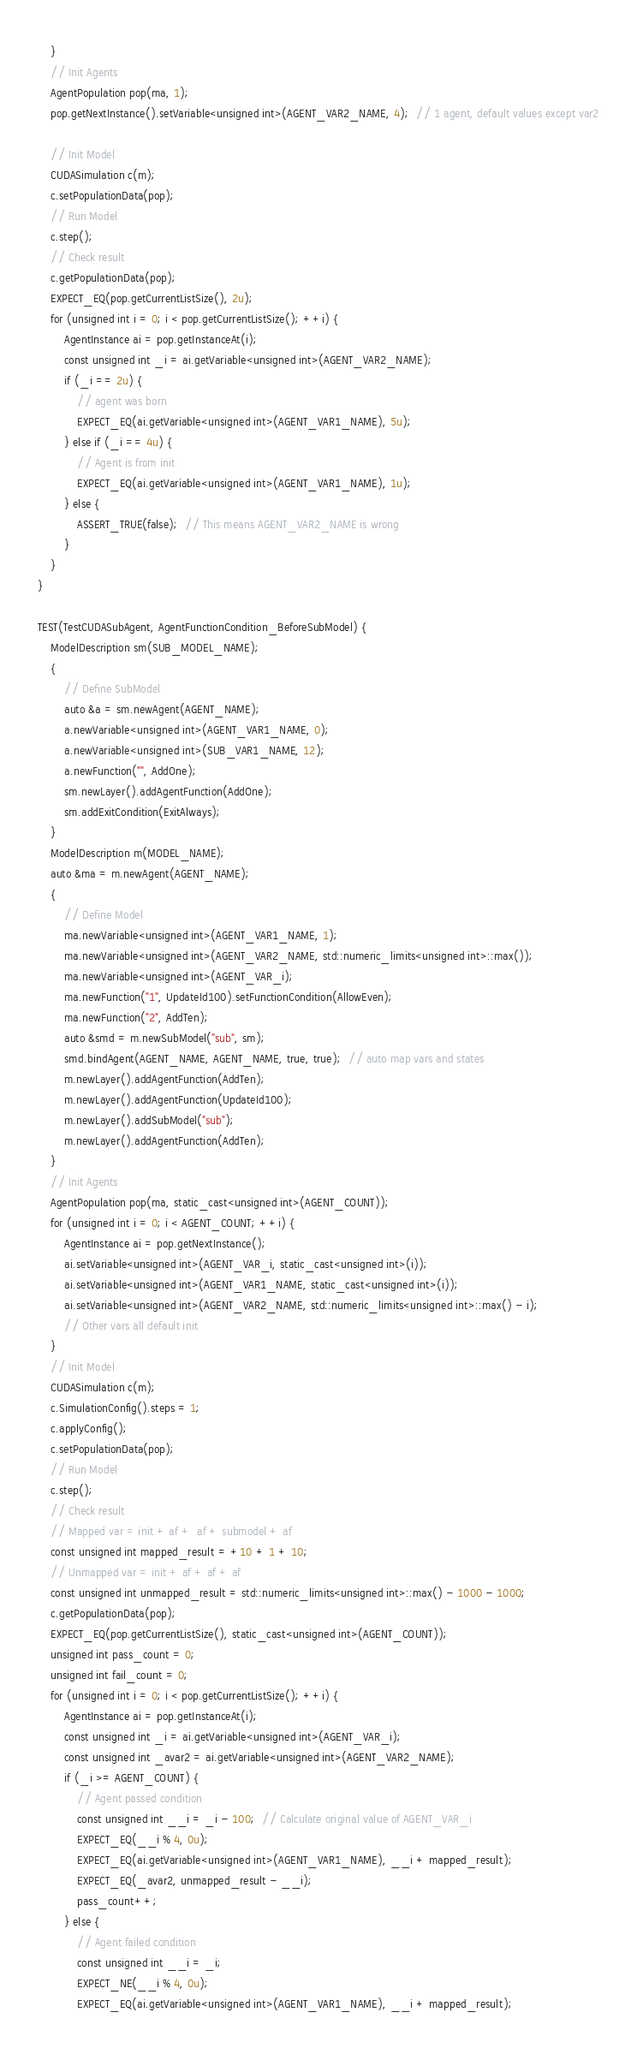Convert code to text. <code><loc_0><loc_0><loc_500><loc_500><_Cuda_>    }
    // Init Agents
    AgentPopulation pop(ma, 1);
    pop.getNextInstance().setVariable<unsigned int>(AGENT_VAR2_NAME, 4);  // 1 agent, default values except var2

    // Init Model
    CUDASimulation c(m);
    c.setPopulationData(pop);
    // Run Model
    c.step();
    // Check result
    c.getPopulationData(pop);
    EXPECT_EQ(pop.getCurrentListSize(), 2u);
    for (unsigned int i = 0; i < pop.getCurrentListSize(); ++i) {
        AgentInstance ai = pop.getInstanceAt(i);
        const unsigned int _i = ai.getVariable<unsigned int>(AGENT_VAR2_NAME);
        if (_i == 2u) {
            // agent was born
            EXPECT_EQ(ai.getVariable<unsigned int>(AGENT_VAR1_NAME), 5u);
        } else if (_i == 4u) {
            // Agent is from init
            EXPECT_EQ(ai.getVariable<unsigned int>(AGENT_VAR1_NAME), 1u);
        } else {
            ASSERT_TRUE(false);  // This means AGENT_VAR2_NAME is wrong
        }
    }
}

TEST(TestCUDASubAgent, AgentFunctionCondition_BeforeSubModel) {
    ModelDescription sm(SUB_MODEL_NAME);
    {
        // Define SubModel
        auto &a = sm.newAgent(AGENT_NAME);
        a.newVariable<unsigned int>(AGENT_VAR1_NAME, 0);
        a.newVariable<unsigned int>(SUB_VAR1_NAME, 12);
        a.newFunction("", AddOne);
        sm.newLayer().addAgentFunction(AddOne);
        sm.addExitCondition(ExitAlways);
    }
    ModelDescription m(MODEL_NAME);
    auto &ma = m.newAgent(AGENT_NAME);
    {
        // Define Model
        ma.newVariable<unsigned int>(AGENT_VAR1_NAME, 1);
        ma.newVariable<unsigned int>(AGENT_VAR2_NAME, std::numeric_limits<unsigned int>::max());
        ma.newVariable<unsigned int>(AGENT_VAR_i);
        ma.newFunction("1", UpdateId100).setFunctionCondition(AllowEven);
        ma.newFunction("2", AddTen);
        auto &smd = m.newSubModel("sub", sm);
        smd.bindAgent(AGENT_NAME, AGENT_NAME, true, true);  // auto map vars and states
        m.newLayer().addAgentFunction(AddTen);
        m.newLayer().addAgentFunction(UpdateId100);
        m.newLayer().addSubModel("sub");
        m.newLayer().addAgentFunction(AddTen);
    }
    // Init Agents
    AgentPopulation pop(ma, static_cast<unsigned int>(AGENT_COUNT));
    for (unsigned int i = 0; i < AGENT_COUNT; ++i) {
        AgentInstance ai = pop.getNextInstance();
        ai.setVariable<unsigned int>(AGENT_VAR_i, static_cast<unsigned int>(i));
        ai.setVariable<unsigned int>(AGENT_VAR1_NAME, static_cast<unsigned int>(i));
        ai.setVariable<unsigned int>(AGENT_VAR2_NAME, std::numeric_limits<unsigned int>::max() - i);
        // Other vars all default init
    }
    // Init Model
    CUDASimulation c(m);
    c.SimulationConfig().steps = 1;
    c.applyConfig();
    c.setPopulationData(pop);
    // Run Model
    c.step();
    // Check result
    // Mapped var = init + af +  af + submodel + af
    const unsigned int mapped_result = +10 + 1 + 10;
    // Unmapped var = init + af + af + af
    const unsigned int unmapped_result = std::numeric_limits<unsigned int>::max() - 1000 - 1000;
    c.getPopulationData(pop);
    EXPECT_EQ(pop.getCurrentListSize(), static_cast<unsigned int>(AGENT_COUNT));
    unsigned int pass_count = 0;
    unsigned int fail_count = 0;
    for (unsigned int i = 0; i < pop.getCurrentListSize(); ++i) {
        AgentInstance ai = pop.getInstanceAt(i);
        const unsigned int _i = ai.getVariable<unsigned int>(AGENT_VAR_i);
        const unsigned int _avar2 = ai.getVariable<unsigned int>(AGENT_VAR2_NAME);
        if (_i >= AGENT_COUNT) {
            // Agent passed condition
            const unsigned int __i = _i - 100;  // Calculate original value of AGENT_VAR_i
            EXPECT_EQ(__i % 4, 0u);
            EXPECT_EQ(ai.getVariable<unsigned int>(AGENT_VAR1_NAME), __i + mapped_result);
            EXPECT_EQ(_avar2, unmapped_result - __i);
            pass_count++;
        } else {
            // Agent failed condition
            const unsigned int __i = _i;
            EXPECT_NE(__i % 4, 0u);
            EXPECT_EQ(ai.getVariable<unsigned int>(AGENT_VAR1_NAME), __i + mapped_result);</code> 